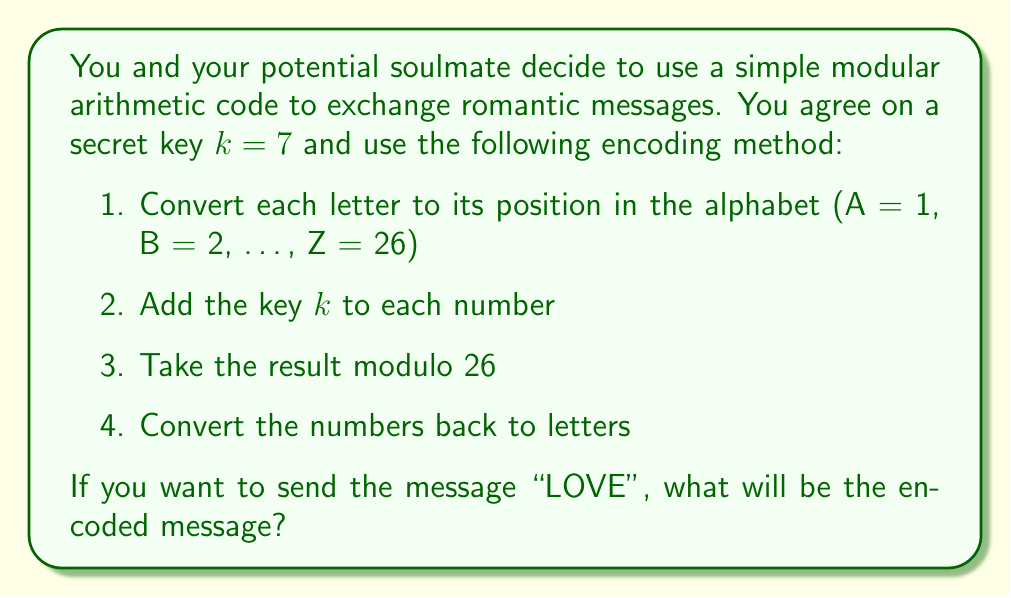Show me your answer to this math problem. Let's follow the steps for each letter in "LOVE":

1. Convert letters to numbers:
   L = 12, O = 15, V = 22, E = 5

2. Add the key $k = 7$ to each number:
   12 + 7 = 19, 15 + 7 = 22, 22 + 7 = 29, 5 + 7 = 12

3. Take each result modulo 26:
   $19 \equiv 19 \pmod{26}$
   $22 \equiv 22 \pmod{26}$
   $29 \equiv 3 \pmod{26}$ (because $29 = 1 \times 26 + 3$)
   $12 \equiv 12 \pmod{26}$

4. Convert numbers back to letters:
   19 = S, 22 = V, 3 = C, 12 = L

Therefore, the encoded message is "SVCL".
Answer: SVCL 